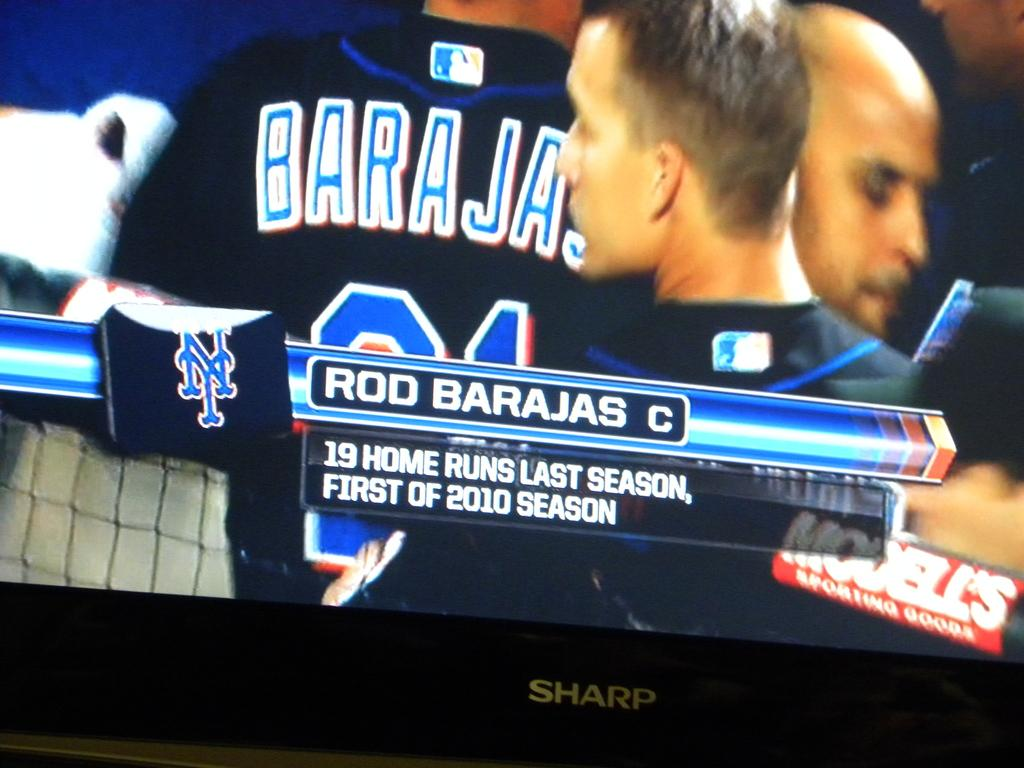<image>
Share a concise interpretation of the image provided. Rod Barajas' season home run statistic is captured on the Sharp television 